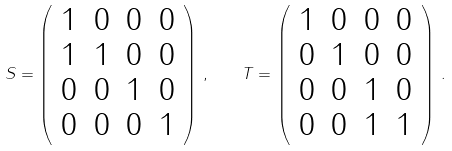Convert formula to latex. <formula><loc_0><loc_0><loc_500><loc_500>S = \left ( \begin{array} { c c c c } 1 & 0 & 0 & 0 \\ 1 & 1 & 0 & 0 \\ 0 & 0 & 1 & 0 \\ 0 & 0 & 0 & 1 \end{array} \right ) \, , \quad T = \left ( \begin{array} { c c c c } 1 & 0 & 0 & 0 \\ 0 & 1 & 0 & 0 \\ 0 & 0 & 1 & 0 \\ 0 & 0 & 1 & 1 \end{array} \right ) \, .</formula> 